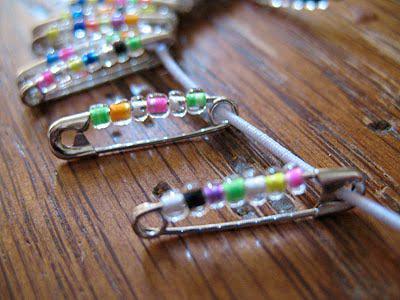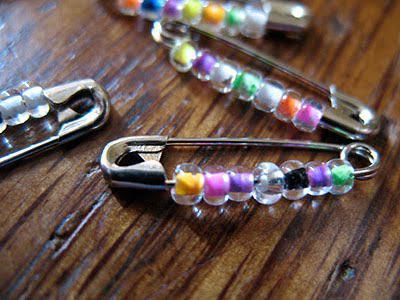The first image is the image on the left, the second image is the image on the right. Analyze the images presented: Is the assertion "At least one of the images displays a pin with a heart pennant." valid? Answer yes or no. No. The first image is the image on the left, the second image is the image on the right. For the images shown, is this caption "An image includes a pin jewelry creation with beads that form a heart shape." true? Answer yes or no. No. The first image is the image on the left, the second image is the image on the right. For the images shown, is this caption "In one of the images there is a group of beaded safety pins that reveal a particular shape." true? Answer yes or no. No. 